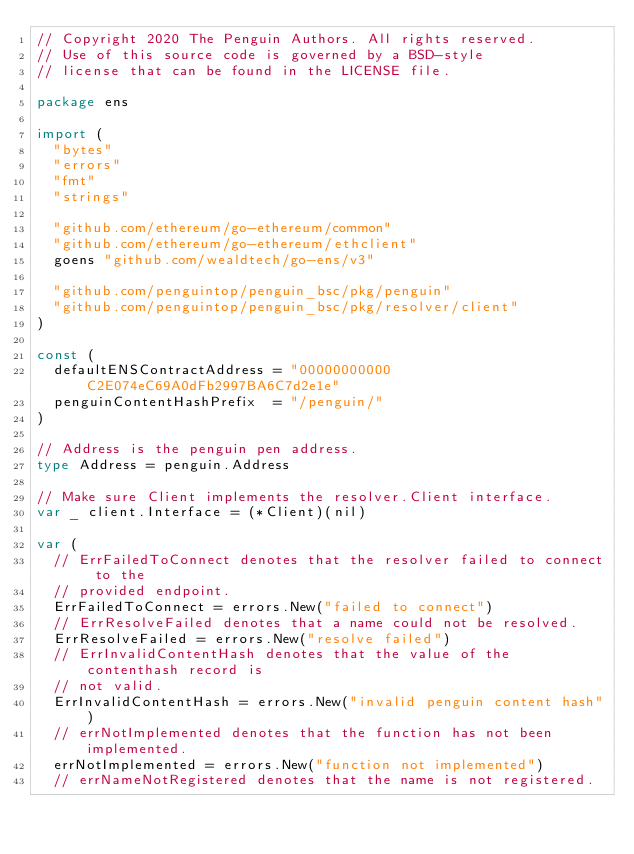Convert code to text. <code><loc_0><loc_0><loc_500><loc_500><_Go_>// Copyright 2020 The Penguin Authors. All rights reserved.
// Use of this source code is governed by a BSD-style
// license that can be found in the LICENSE file.

package ens

import (
	"bytes"
	"errors"
	"fmt"
	"strings"

	"github.com/ethereum/go-ethereum/common"
	"github.com/ethereum/go-ethereum/ethclient"
	goens "github.com/wealdtech/go-ens/v3"

	"github.com/penguintop/penguin_bsc/pkg/penguin"
	"github.com/penguintop/penguin_bsc/pkg/resolver/client"
)

const (
	defaultENSContractAddress = "00000000000C2E074eC69A0dFb2997BA6C7d2e1e"
	penguinContentHashPrefix  = "/penguin/"
)

// Address is the penguin pen address.
type Address = penguin.Address

// Make sure Client implements the resolver.Client interface.
var _ client.Interface = (*Client)(nil)

var (
	// ErrFailedToConnect denotes that the resolver failed to connect to the
	// provided endpoint.
	ErrFailedToConnect = errors.New("failed to connect")
	// ErrResolveFailed denotes that a name could not be resolved.
	ErrResolveFailed = errors.New("resolve failed")
	// ErrInvalidContentHash denotes that the value of the contenthash record is
	// not valid.
	ErrInvalidContentHash = errors.New("invalid penguin content hash")
	// errNotImplemented denotes that the function has not been implemented.
	errNotImplemented = errors.New("function not implemented")
	// errNameNotRegistered denotes that the name is not registered.</code> 